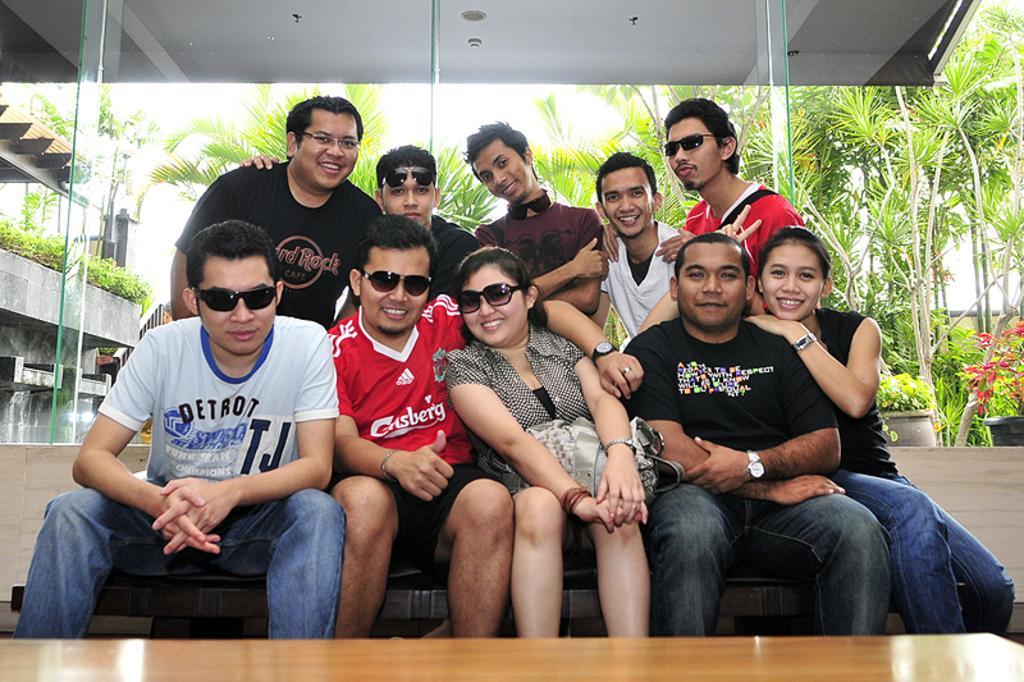Can you describe this image briefly? There are people sitting in front of a table in the foreground area of the image, there are glass windows, greenery, building and the sky in the background. 